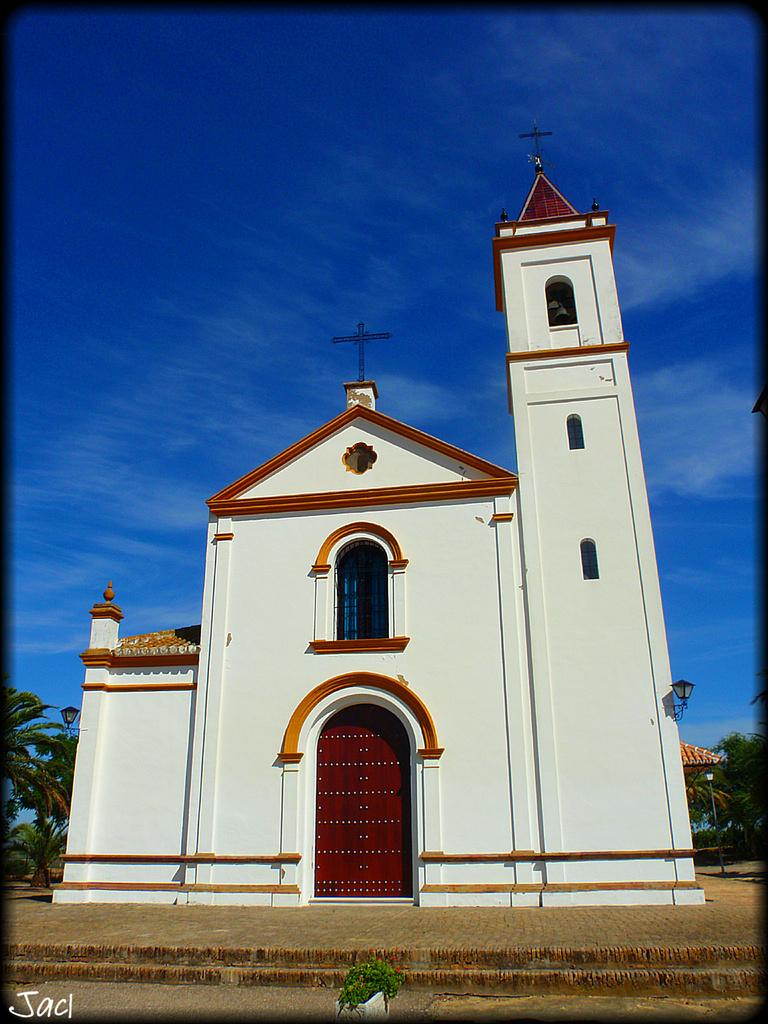What type of building is in the image? There is a church building in the image. What color is the church building? The church building is white in color. What is on top of the church building? The church building has a cross on top. What can be seen behind the church building? There are trees visible behind the church building. How many legs does the church building have in the image? The church building does not have legs; it is a stationary structure. 